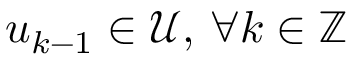Convert formula to latex. <formula><loc_0><loc_0><loc_500><loc_500>u _ { k - 1 } \in \mathcal { U } , \, \forall k \in \mathbb { Z }</formula> 